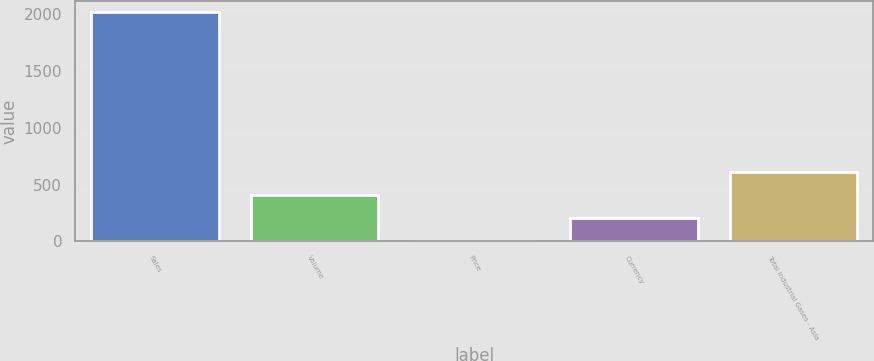Convert chart to OTSL. <chart><loc_0><loc_0><loc_500><loc_500><bar_chart><fcel>Sales<fcel>Volume<fcel>Price<fcel>Currency<fcel>Total Industrial Gases - Asia<nl><fcel>2018<fcel>406.8<fcel>4<fcel>205.4<fcel>608.2<nl></chart> 